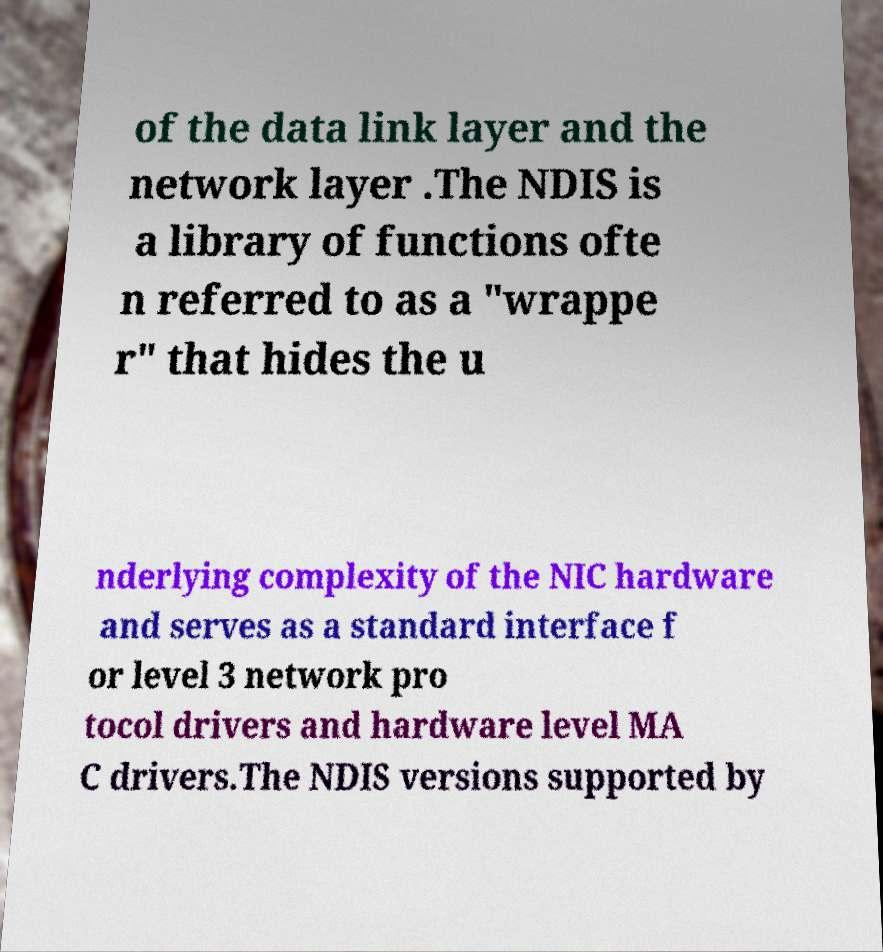For documentation purposes, I need the text within this image transcribed. Could you provide that? of the data link layer and the network layer .The NDIS is a library of functions ofte n referred to as a "wrappe r" that hides the u nderlying complexity of the NIC hardware and serves as a standard interface f or level 3 network pro tocol drivers and hardware level MA C drivers.The NDIS versions supported by 